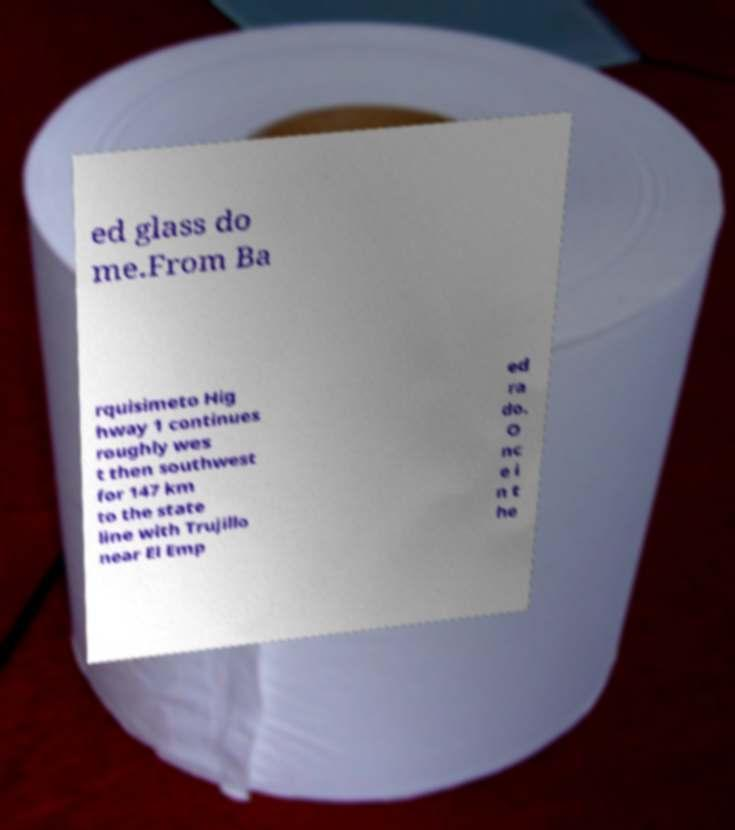I need the written content from this picture converted into text. Can you do that? ed glass do me.From Ba rquisimeto Hig hway 1 continues roughly wes t then southwest for 147 km to the state line with Trujillo near El Emp ed ra do. O nc e i n t he 